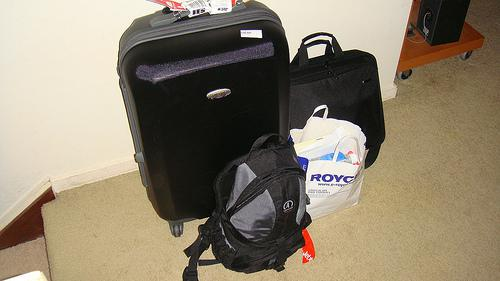Question: what is black?
Choices:
A. Mini-skirt.
B. Luggage.
C. Shoes.
D. Car.
Answer with the letter. Answer: B Question: what is white?
Choices:
A. The paper bag.
B. The man's shirt.
C. The car.
D. The cup.
Answer with the letter. Answer: A Question: what is tan?
Choices:
A. Wall.
B. Carpet.
C. Cat.
D. Dog.
Answer with the letter. Answer: B Question: why is the luggage out?
Choices:
A. Just getting home.
B. Moving out.
C. For the kids to play with.
D. Taking a trip.
Answer with the letter. Answer: D Question: where is the luggage sitting?
Choices:
A. By the door.
B. In the car trunk.
C. Top of the stairs.
D. Next to the car.
Answer with the letter. Answer: C Question: how many pieces of luggage?
Choices:
A. Four.
B. Seven.
C. Three.
D. Five.
Answer with the letter. Answer: C 